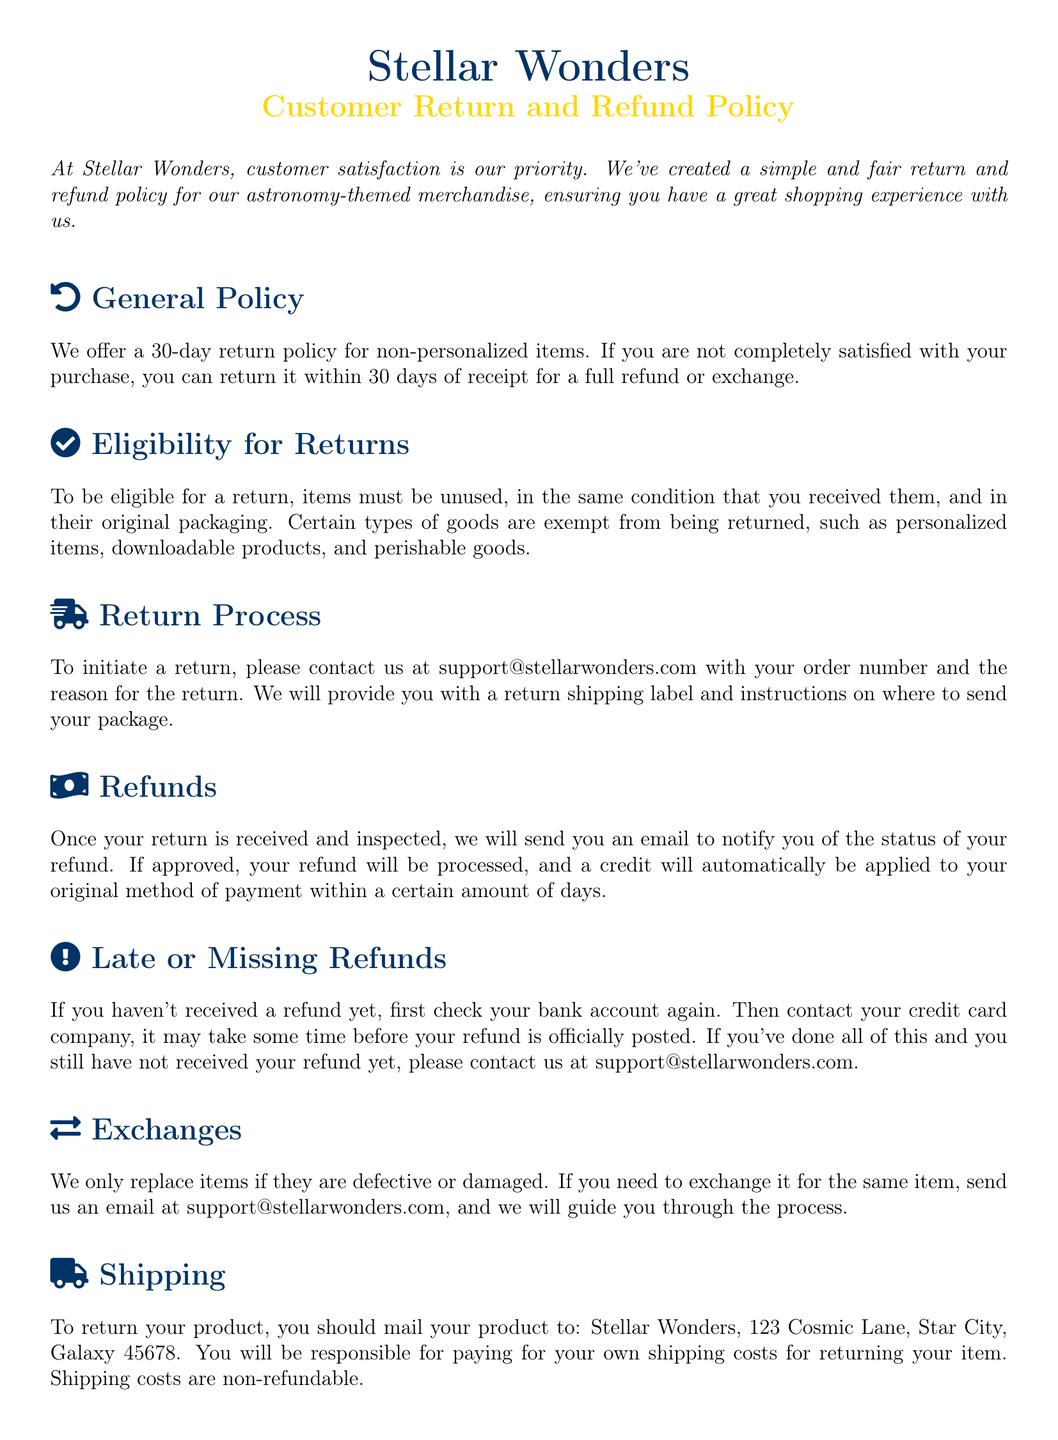What is the return policy duration? The return policy duration mentioned in the document is 30 days.
Answer: 30 days What types of items are exempt from returns? The document states that personalized items, downloadable products, and perishable goods are exempt from returns.
Answer: Personalized items, downloadable products, and perishable goods What should you include in your return request email? The document specifies that you should include your order number and the reason for the return in your email.
Answer: Order number and reason for return What do you need to do if you haven't received your refund? According to the document, you should check your bank account and contact your credit card company if necessary.
Answer: Check bank account and contact credit card company How are exchanges handled? The document explains that they only replace items if they are defective or damaged.
Answer: Defective or damaged What address should products be mailed to for returns? The document provides the address Stellar Wonders, 123 Cosmic Lane, Star City, Galaxy 45678 for returns.
Answer: Stellar Wonders, 123 Cosmic Lane, Star City, Galaxy 45678 